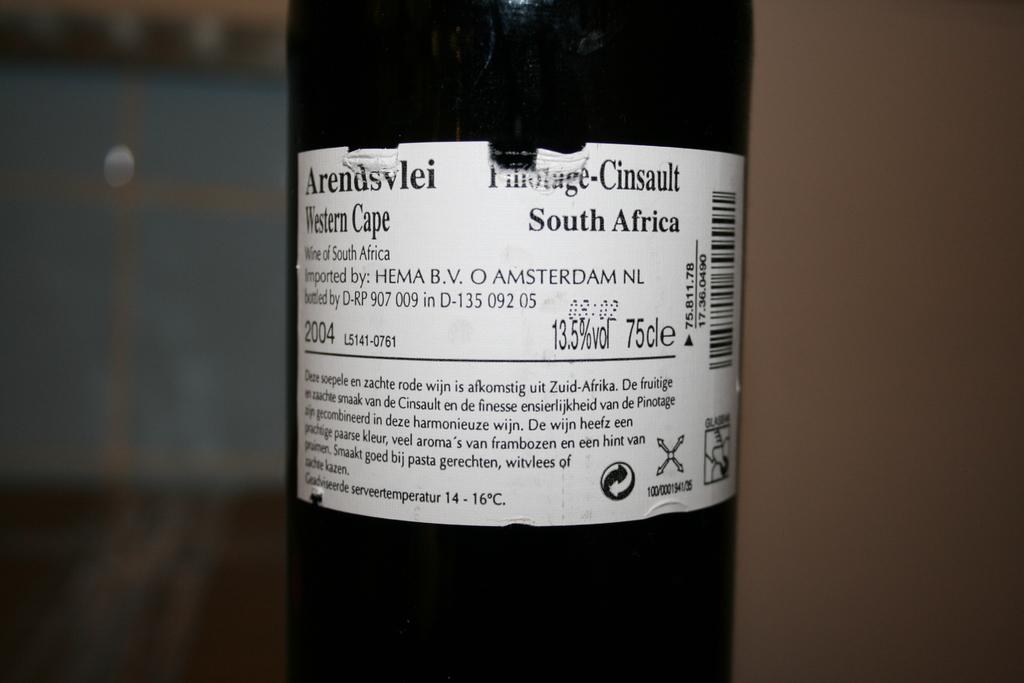<image>
Offer a succinct explanation of the picture presented. Black bottle with a white label that says South Africa. 